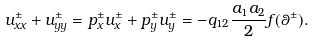<formula> <loc_0><loc_0><loc_500><loc_500>u _ { x x } ^ { \pm } + u _ { y y } ^ { \pm } = p _ { x } ^ { \pm } u _ { x } ^ { \pm } + p _ { y } ^ { \pm } u _ { y } ^ { \pm } = - q _ { 1 2 } \frac { a _ { 1 } a _ { 2 } } { 2 } f ( \theta ^ { \pm } ) .</formula> 